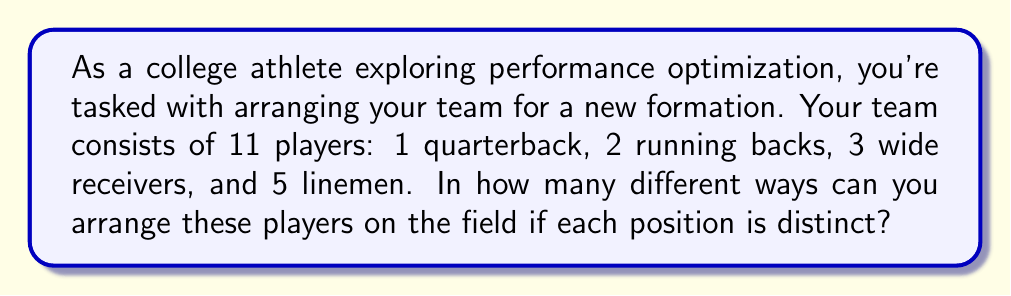Give your solution to this math problem. Let's approach this step-by-step:

1) This is a permutation problem because the order matters (each position is distinct) and we're using all players.

2) We have 11 distinct positions to fill with 11 players.

3) The formula for permutations of n distinct objects is:

   $$P(n) = n!$$

4) In this case, n = 11, so we calculate:

   $$P(11) = 11!$$

5) Let's expand this:

   $$11! = 11 \times 10 \times 9 \times 8 \times 7 \times 6 \times 5 \times 4 \times 3 \times 2 \times 1$$

6) Calculating this out:

   $$11! = 39,916,800$$

This means there are 39,916,800 different ways to arrange the 11 players in the 11 distinct positions on the field.

Note: This calculation assumes that any player can play any position. In a real football scenario, players are typically specialized for certain positions, which would reduce the number of possible arrangements. However, for the purpose of this permutation problem, we're considering all possible arrangements.
Answer: $39,916,800$ 